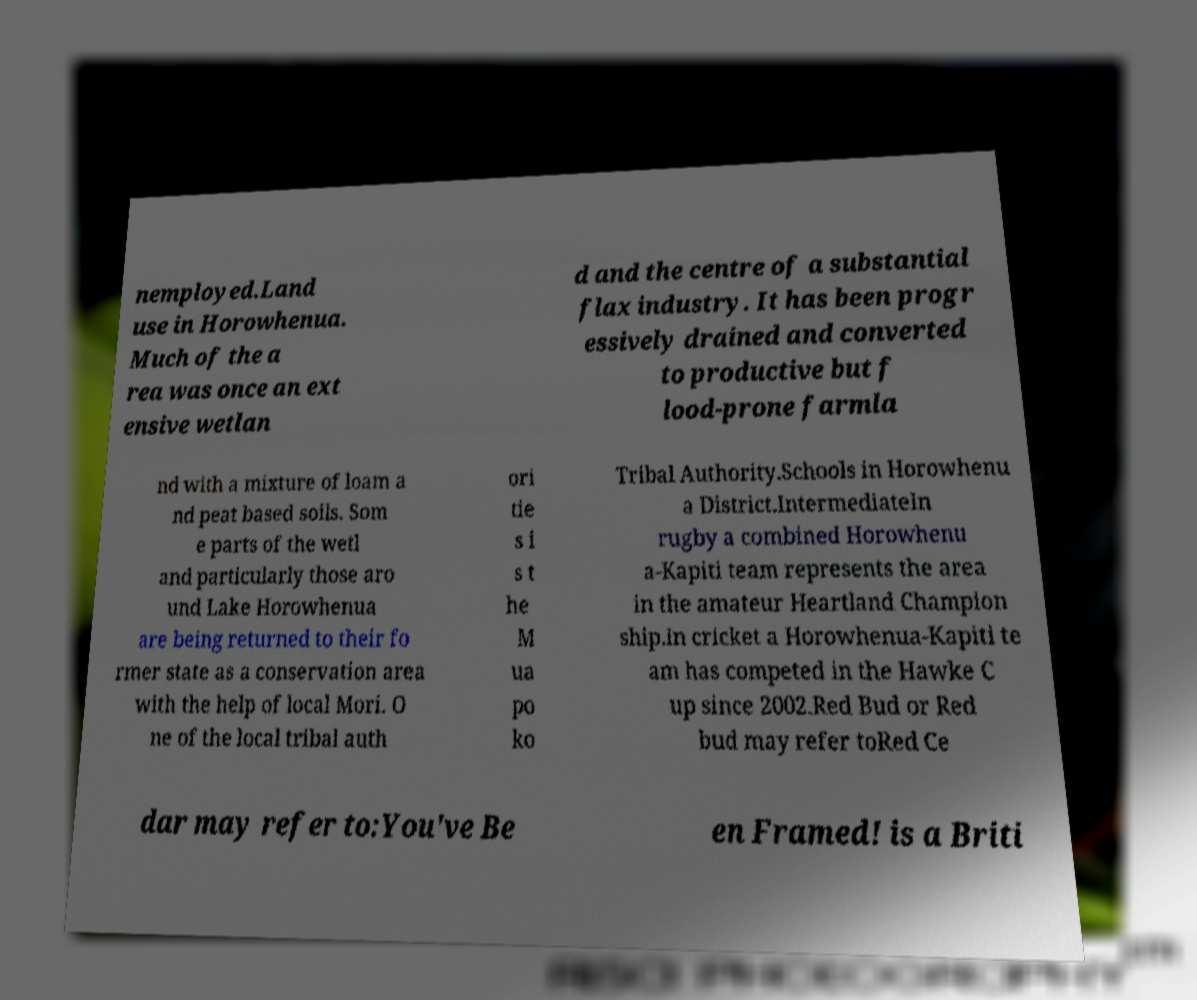Can you read and provide the text displayed in the image?This photo seems to have some interesting text. Can you extract and type it out for me? nemployed.Land use in Horowhenua. Much of the a rea was once an ext ensive wetlan d and the centre of a substantial flax industry. It has been progr essively drained and converted to productive but f lood-prone farmla nd with a mixture of loam a nd peat based soils. Som e parts of the wetl and particularly those aro und Lake Horowhenua are being returned to their fo rmer state as a conservation area with the help of local Mori. O ne of the local tribal auth ori tie s i s t he M ua po ko Tribal Authority.Schools in Horowhenu a District.IntermediateIn rugby a combined Horowhenu a-Kapiti team represents the area in the amateur Heartland Champion ship.In cricket a Horowhenua-Kapiti te am has competed in the Hawke C up since 2002.Red Bud or Red bud may refer toRed Ce dar may refer to:You've Be en Framed! is a Briti 